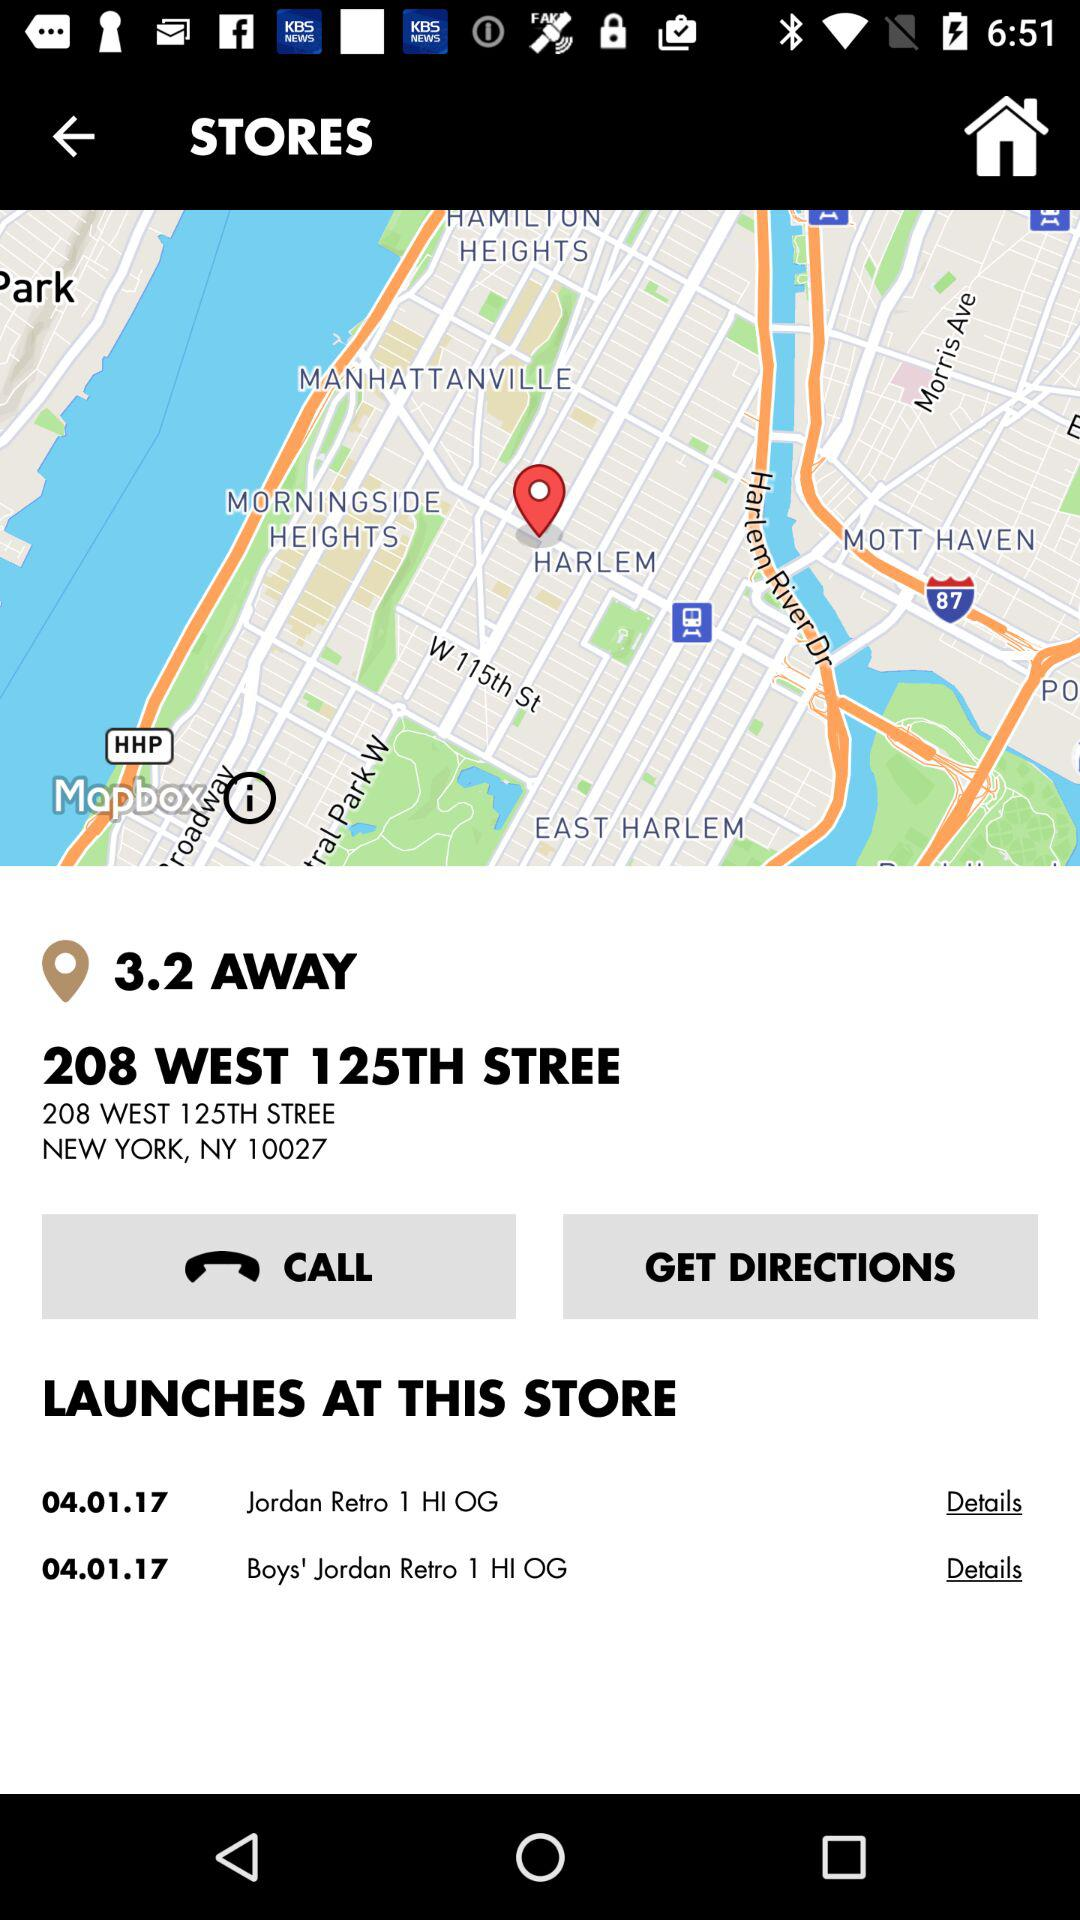How many items are available for boys?
Answer the question using a single word or phrase. 1 